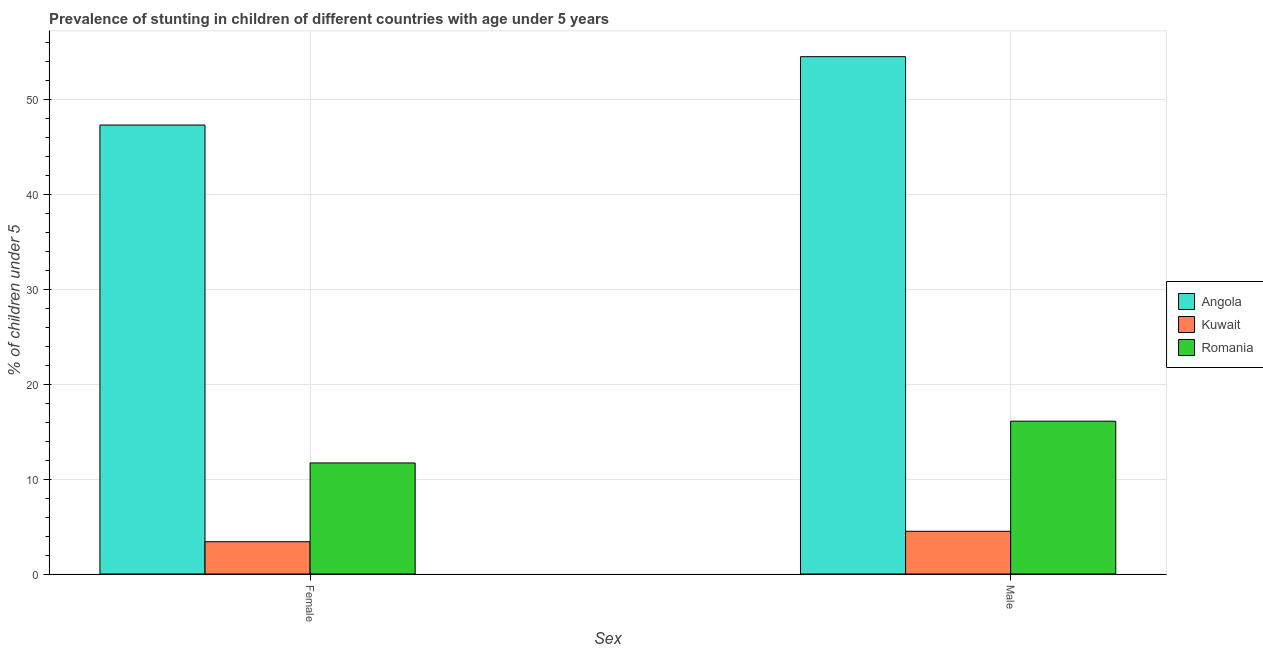How many different coloured bars are there?
Provide a short and direct response. 3. How many groups of bars are there?
Your answer should be compact. 2. How many bars are there on the 1st tick from the left?
Your answer should be compact. 3. Across all countries, what is the maximum percentage of stunted male children?
Provide a succinct answer. 54.5. Across all countries, what is the minimum percentage of stunted male children?
Offer a very short reply. 4.5. In which country was the percentage of stunted male children maximum?
Offer a very short reply. Angola. In which country was the percentage of stunted female children minimum?
Provide a succinct answer. Kuwait. What is the total percentage of stunted female children in the graph?
Your response must be concise. 62.4. What is the difference between the percentage of stunted female children in Kuwait and that in Angola?
Provide a short and direct response. -43.9. What is the difference between the percentage of stunted male children in Kuwait and the percentage of stunted female children in Romania?
Give a very brief answer. -7.2. What is the average percentage of stunted female children per country?
Offer a very short reply. 20.8. What is the difference between the percentage of stunted female children and percentage of stunted male children in Kuwait?
Keep it short and to the point. -1.1. In how many countries, is the percentage of stunted female children greater than 18 %?
Keep it short and to the point. 1. What is the ratio of the percentage of stunted male children in Romania to that in Angola?
Offer a very short reply. 0.3. Is the percentage of stunted female children in Angola less than that in Kuwait?
Make the answer very short. No. What does the 3rd bar from the left in Male represents?
Offer a very short reply. Romania. What does the 1st bar from the right in Female represents?
Provide a succinct answer. Romania. Are all the bars in the graph horizontal?
Offer a terse response. No. How many countries are there in the graph?
Provide a succinct answer. 3. Does the graph contain grids?
Provide a short and direct response. Yes. Where does the legend appear in the graph?
Offer a very short reply. Center right. How many legend labels are there?
Offer a very short reply. 3. What is the title of the graph?
Your answer should be compact. Prevalence of stunting in children of different countries with age under 5 years. Does "Djibouti" appear as one of the legend labels in the graph?
Your answer should be compact. No. What is the label or title of the X-axis?
Give a very brief answer. Sex. What is the label or title of the Y-axis?
Provide a succinct answer.  % of children under 5. What is the  % of children under 5 of Angola in Female?
Provide a short and direct response. 47.3. What is the  % of children under 5 in Kuwait in Female?
Your answer should be very brief. 3.4. What is the  % of children under 5 in Romania in Female?
Provide a short and direct response. 11.7. What is the  % of children under 5 of Angola in Male?
Offer a very short reply. 54.5. What is the  % of children under 5 of Romania in Male?
Provide a succinct answer. 16.1. Across all Sex, what is the maximum  % of children under 5 of Angola?
Make the answer very short. 54.5. Across all Sex, what is the maximum  % of children under 5 in Kuwait?
Make the answer very short. 4.5. Across all Sex, what is the maximum  % of children under 5 in Romania?
Offer a terse response. 16.1. Across all Sex, what is the minimum  % of children under 5 in Angola?
Ensure brevity in your answer.  47.3. Across all Sex, what is the minimum  % of children under 5 of Kuwait?
Your response must be concise. 3.4. Across all Sex, what is the minimum  % of children under 5 of Romania?
Your response must be concise. 11.7. What is the total  % of children under 5 in Angola in the graph?
Your answer should be compact. 101.8. What is the total  % of children under 5 in Kuwait in the graph?
Keep it short and to the point. 7.9. What is the total  % of children under 5 in Romania in the graph?
Your answer should be very brief. 27.8. What is the difference between the  % of children under 5 of Kuwait in Female and that in Male?
Offer a very short reply. -1.1. What is the difference between the  % of children under 5 in Angola in Female and the  % of children under 5 in Kuwait in Male?
Your answer should be very brief. 42.8. What is the difference between the  % of children under 5 of Angola in Female and the  % of children under 5 of Romania in Male?
Ensure brevity in your answer.  31.2. What is the difference between the  % of children under 5 in Kuwait in Female and the  % of children under 5 in Romania in Male?
Your answer should be compact. -12.7. What is the average  % of children under 5 in Angola per Sex?
Provide a succinct answer. 50.9. What is the average  % of children under 5 of Kuwait per Sex?
Keep it short and to the point. 3.95. What is the difference between the  % of children under 5 in Angola and  % of children under 5 in Kuwait in Female?
Give a very brief answer. 43.9. What is the difference between the  % of children under 5 of Angola and  % of children under 5 of Romania in Female?
Offer a very short reply. 35.6. What is the difference between the  % of children under 5 of Kuwait and  % of children under 5 of Romania in Female?
Offer a terse response. -8.3. What is the difference between the  % of children under 5 in Angola and  % of children under 5 in Romania in Male?
Provide a succinct answer. 38.4. What is the ratio of the  % of children under 5 of Angola in Female to that in Male?
Offer a terse response. 0.87. What is the ratio of the  % of children under 5 of Kuwait in Female to that in Male?
Your answer should be compact. 0.76. What is the ratio of the  % of children under 5 in Romania in Female to that in Male?
Ensure brevity in your answer.  0.73. What is the difference between the highest and the second highest  % of children under 5 in Angola?
Make the answer very short. 7.2. What is the difference between the highest and the second highest  % of children under 5 in Kuwait?
Provide a succinct answer. 1.1. What is the difference between the highest and the lowest  % of children under 5 in Angola?
Your answer should be very brief. 7.2. What is the difference between the highest and the lowest  % of children under 5 of Romania?
Offer a terse response. 4.4. 